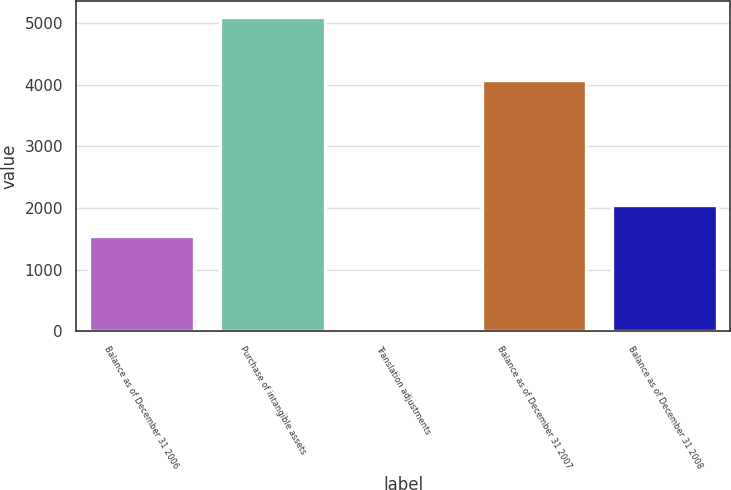Convert chart to OTSL. <chart><loc_0><loc_0><loc_500><loc_500><bar_chart><fcel>Balance as of December 31 2006<fcel>Purchase of intangible assets<fcel>Translation adjustments<fcel>Balance as of December 31 2007<fcel>Balance as of December 31 2008<nl><fcel>1540<fcel>5100<fcel>29<fcel>4075<fcel>2047.1<nl></chart> 